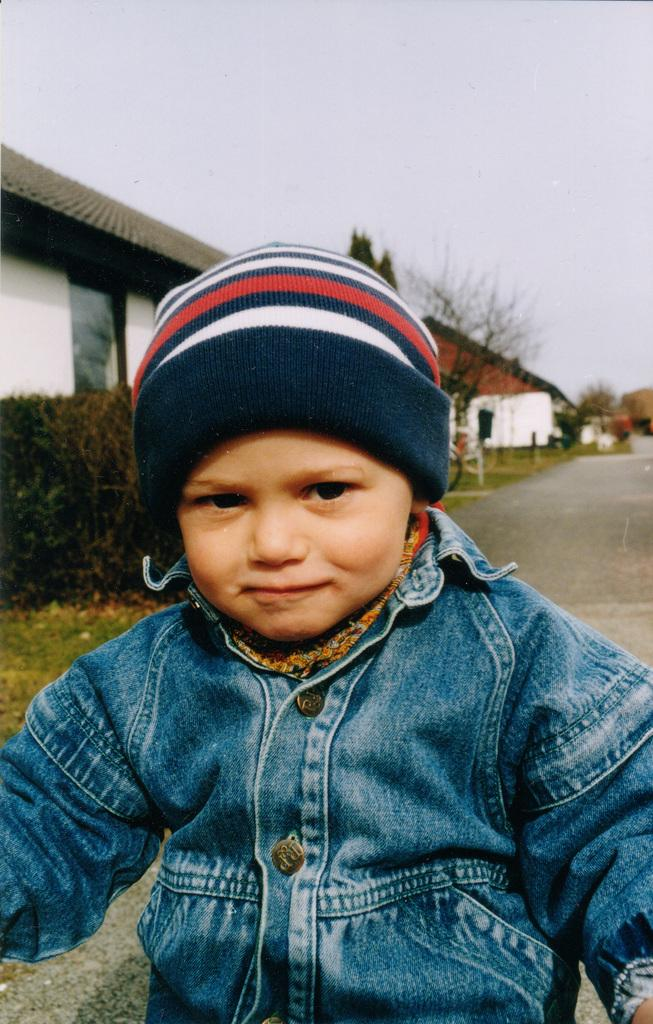Who is the main subject in the image? There is a boy in the image. What can be seen in the background of the image? There are houses, a road, trees, and the sky visible in the background of the image. How many women are present in the image? There are no women present in the image; it features a boy and various elements in the background. What type of class is being held in the image? There is no class present in the image; it shows a boy and the background elements mentioned earlier. 